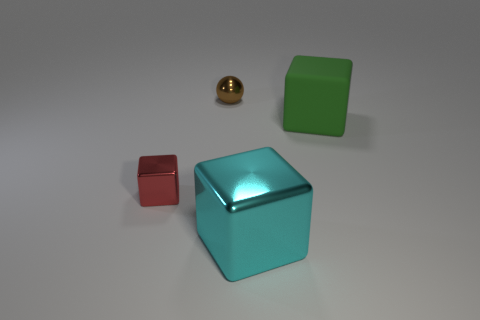What number of other objects are the same size as the cyan metallic thing?
Your answer should be compact. 1. What is the cube that is to the left of the big green rubber object and behind the cyan cube made of?
Your response must be concise. Metal. How many cyan shiny cubes are on the right side of the large cyan object?
Your answer should be compact. 0. There is a brown shiny thing; is it the same shape as the large object in front of the tiny red metallic thing?
Ensure brevity in your answer.  No. Is there a brown thing of the same shape as the tiny red object?
Your response must be concise. No. What is the shape of the small metal thing that is behind the metal cube behind the big metallic cube?
Offer a very short reply. Sphere. There is a small thing that is behind the large rubber block; what is its shape?
Your answer should be compact. Sphere. Is the color of the object that is to the right of the cyan shiny object the same as the tiny thing behind the red metallic cube?
Your answer should be very brief. No. How many things are both behind the small shiny cube and in front of the metallic sphere?
Offer a very short reply. 1. There is a cyan thing that is made of the same material as the tiny sphere; what size is it?
Your answer should be very brief. Large. 